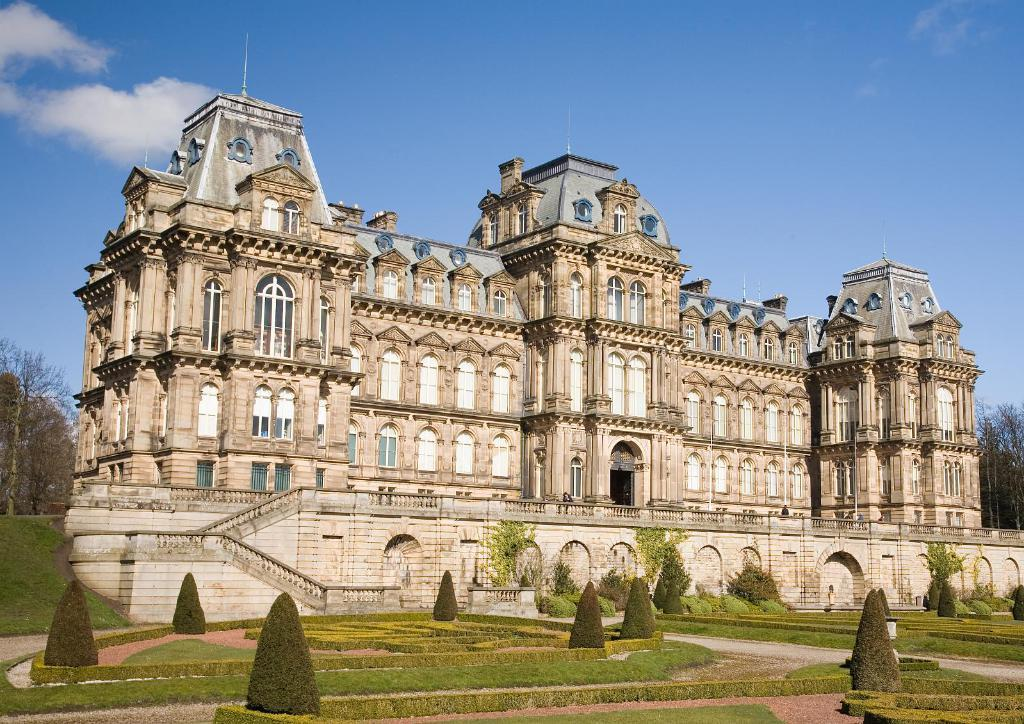What type of structure is in the image? There is a fort in the image. What is located in front of the fort? Bushes and plants are in front of the fort. What is visible at the top of the image? The sky is visible at the top of the image. What type of flame can be seen coming from the building in the image? There is no building or flame present in the image; it features a fort with bushes and plants in front of it. 